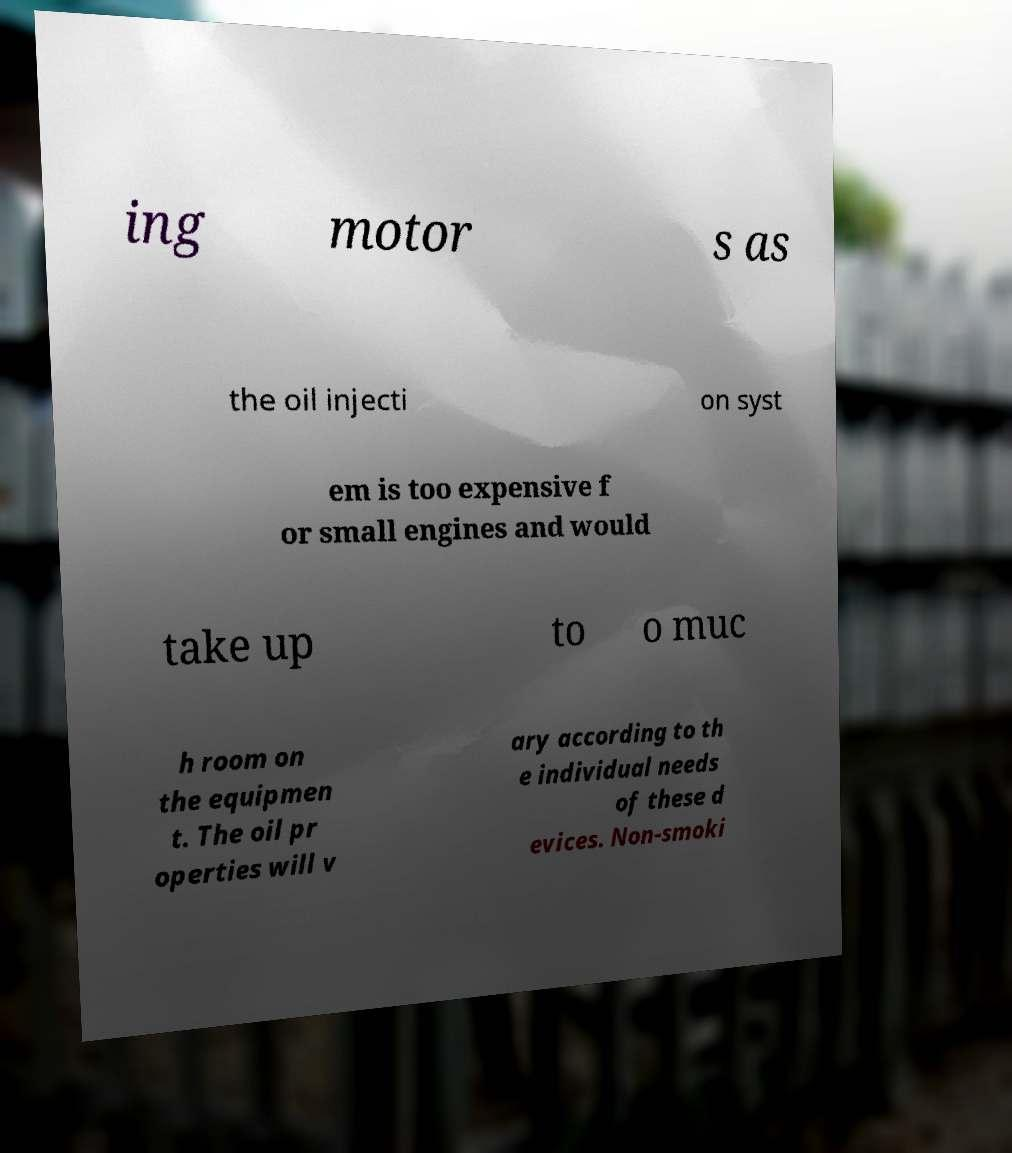For documentation purposes, I need the text within this image transcribed. Could you provide that? ing motor s as the oil injecti on syst em is too expensive f or small engines and would take up to o muc h room on the equipmen t. The oil pr operties will v ary according to th e individual needs of these d evices. Non-smoki 